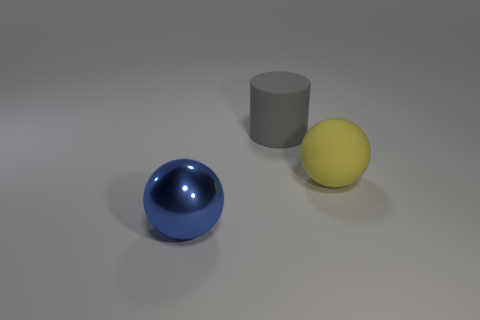Add 3 purple cubes. How many objects exist? 6 Subtract all cylinders. How many objects are left? 2 Add 2 large gray rubber cylinders. How many large gray rubber cylinders are left? 3 Add 3 big gray matte cylinders. How many big gray matte cylinders exist? 4 Subtract 0 red cubes. How many objects are left? 3 Subtract all large blue metallic things. Subtract all rubber spheres. How many objects are left? 1 